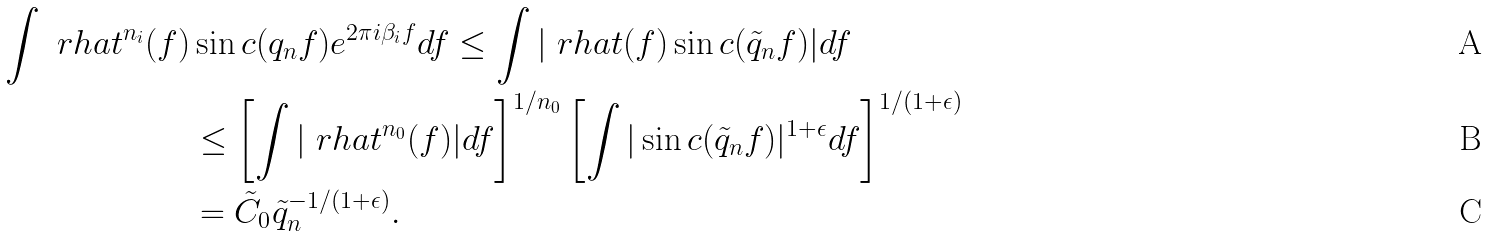Convert formula to latex. <formula><loc_0><loc_0><loc_500><loc_500>\int \ r h a t ^ { n _ { i } } ( f ) & \sin c ( q _ { n } f ) e ^ { 2 \pi i \beta _ { i } f } d f \leq \int | \ r h a t ( f ) \sin c ( \tilde { q } _ { n } f ) | d f \\ & \leq \left [ \int | \ r h a t ^ { n _ { 0 } } ( f ) | d f \right ] ^ { 1 / n _ { 0 } } \left [ \int | \sin c ( \tilde { q } _ { n } f ) | ^ { 1 + \epsilon } d f \right ] ^ { 1 / ( 1 + \epsilon ) } \\ & = \tilde { C } _ { 0 } \tilde { q } _ { n } ^ { - 1 / ( 1 + \epsilon ) } .</formula> 